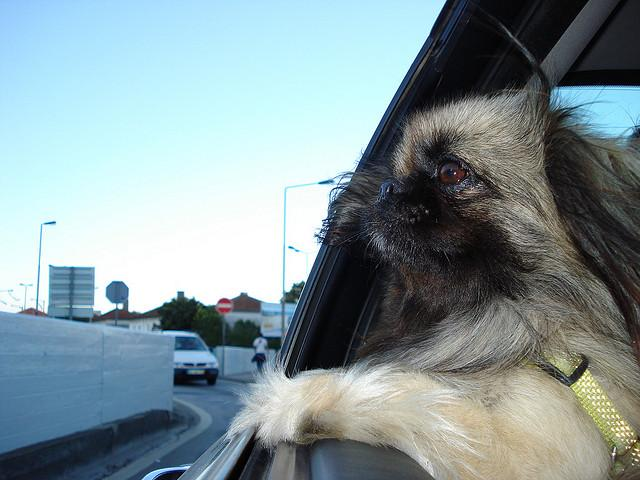What kind of pet is looking out the window?

Choices:
A) cat
B) rabbit
C) dog
D) hamster cat 